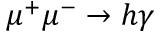<formula> <loc_0><loc_0><loc_500><loc_500>\mu ^ { + } \mu ^ { - } \to h \gamma</formula> 